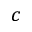Convert formula to latex. <formula><loc_0><loc_0><loc_500><loc_500>c</formula> 